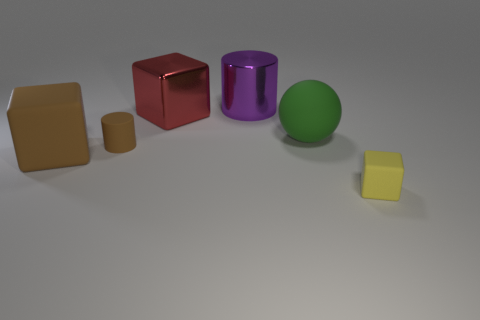What number of objects have the same color as the tiny cylinder?
Your answer should be compact. 1. There is another metallic thing that is the same size as the red metallic thing; what is its shape?
Your answer should be very brief. Cylinder. What number of cubes are in front of the big green matte ball and left of the green matte thing?
Provide a succinct answer. 1. There is a cube to the right of the ball; what is its material?
Make the answer very short. Rubber. There is a yellow object that is made of the same material as the brown cylinder; what is its size?
Ensure brevity in your answer.  Small. Does the red thing that is on the left side of the big purple metallic object have the same size as the purple object behind the large red metallic block?
Your answer should be very brief. Yes. There is a purple object that is the same size as the red metal thing; what is it made of?
Provide a short and direct response. Metal. There is a block that is both in front of the green rubber thing and left of the green sphere; what material is it?
Give a very brief answer. Rubber. Are any red metallic blocks visible?
Your answer should be very brief. Yes. There is a tiny cylinder; does it have the same color as the rubber block to the left of the shiny cylinder?
Provide a succinct answer. Yes. 